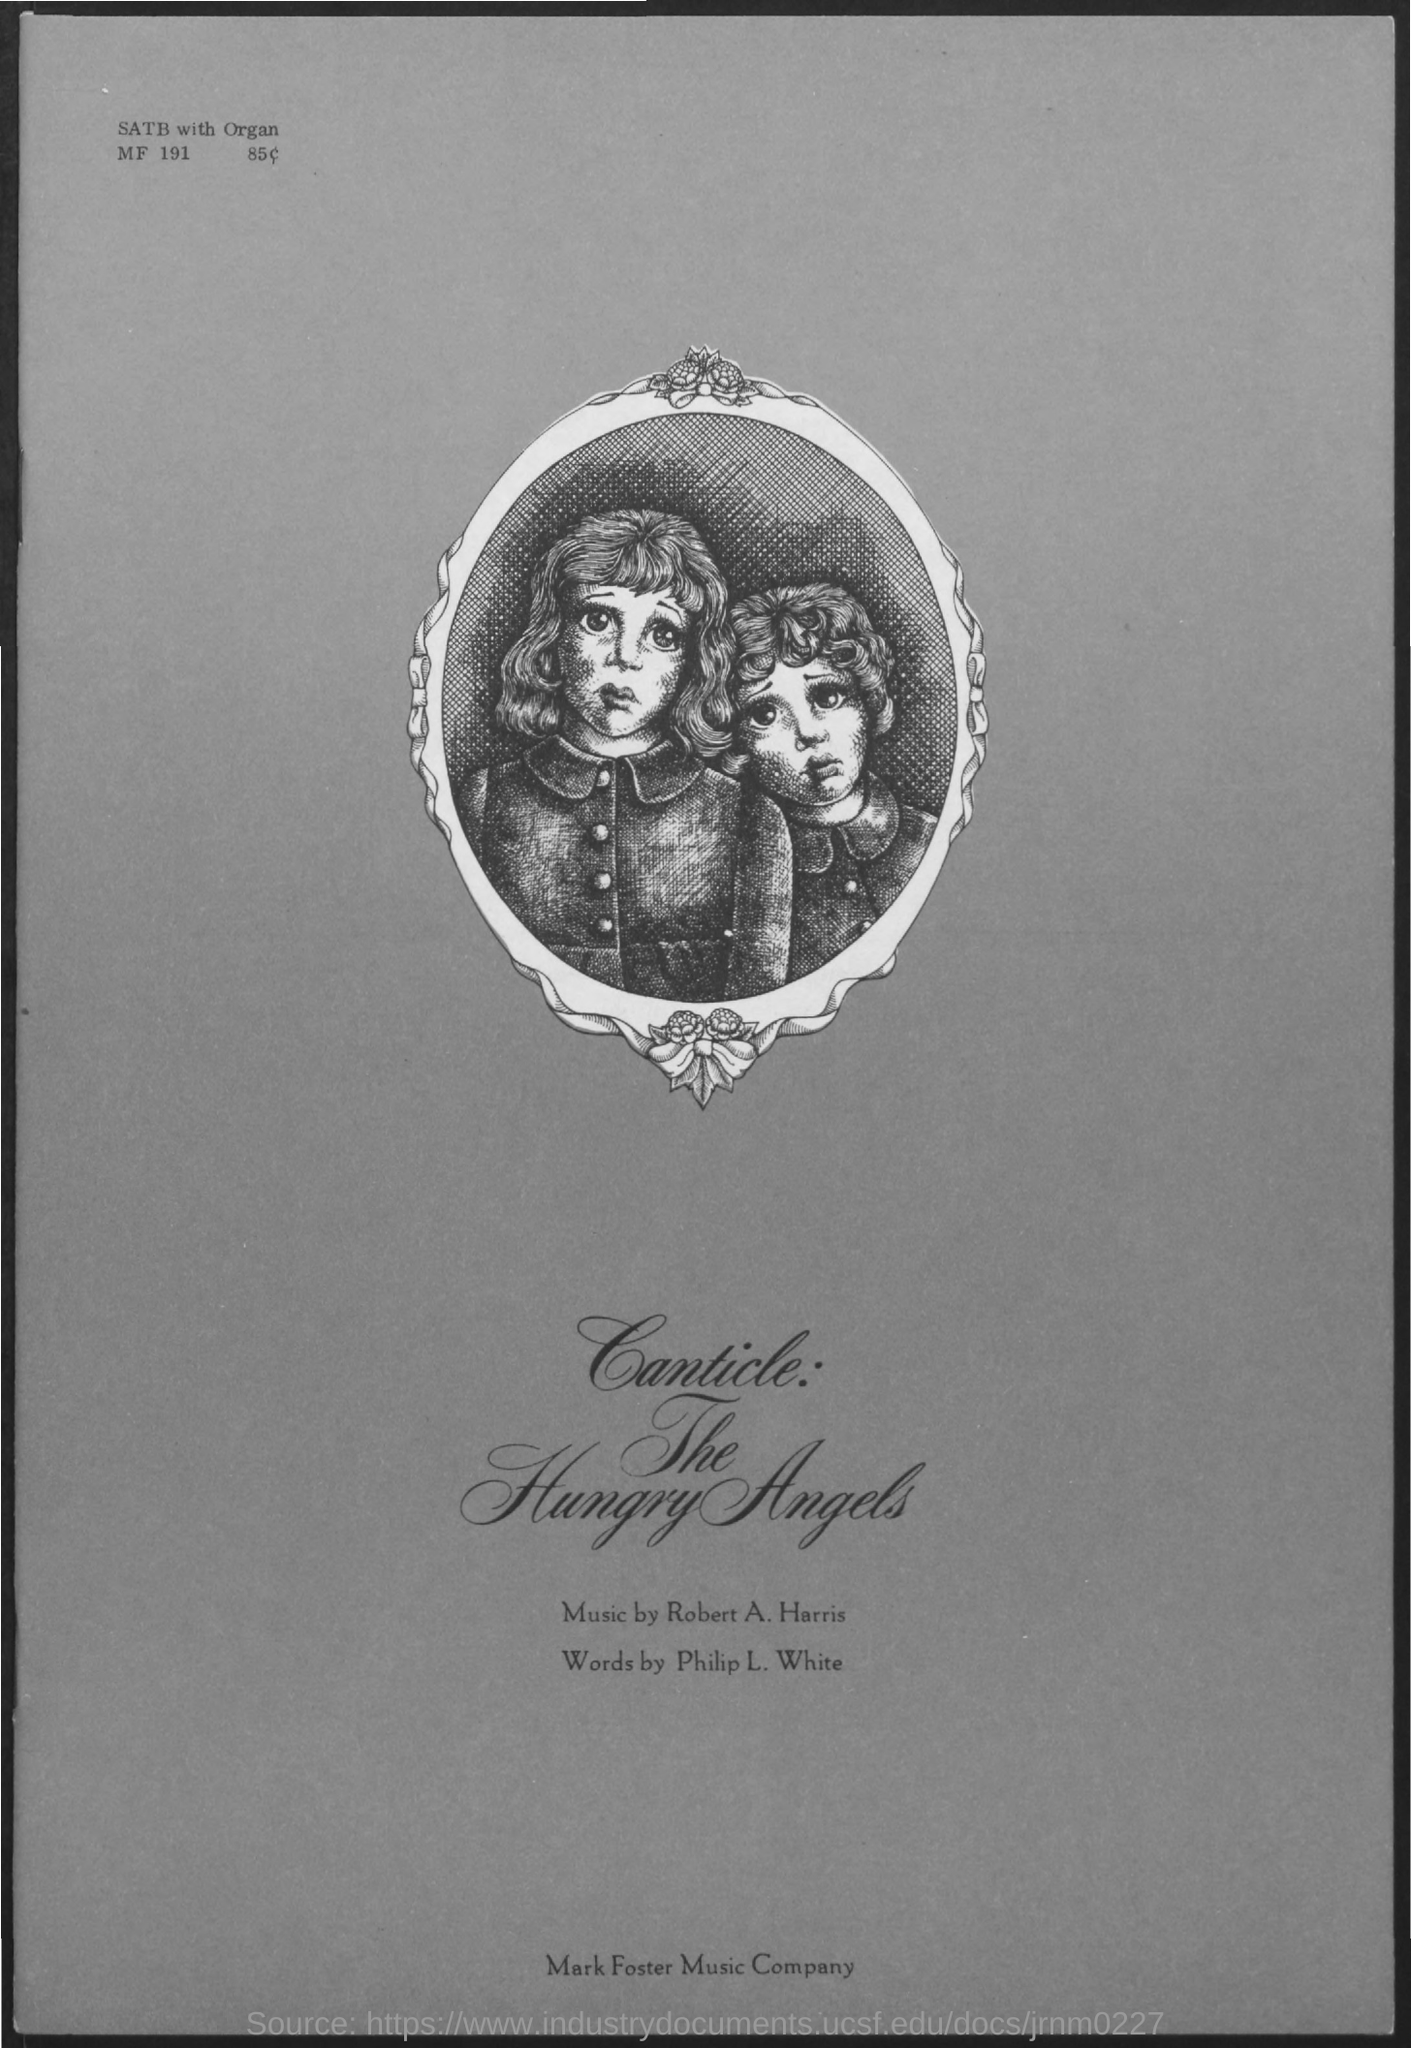Outline some significant characteristics in this image. The words were written by Philip L. White. Robert A. Harris composed the music. 